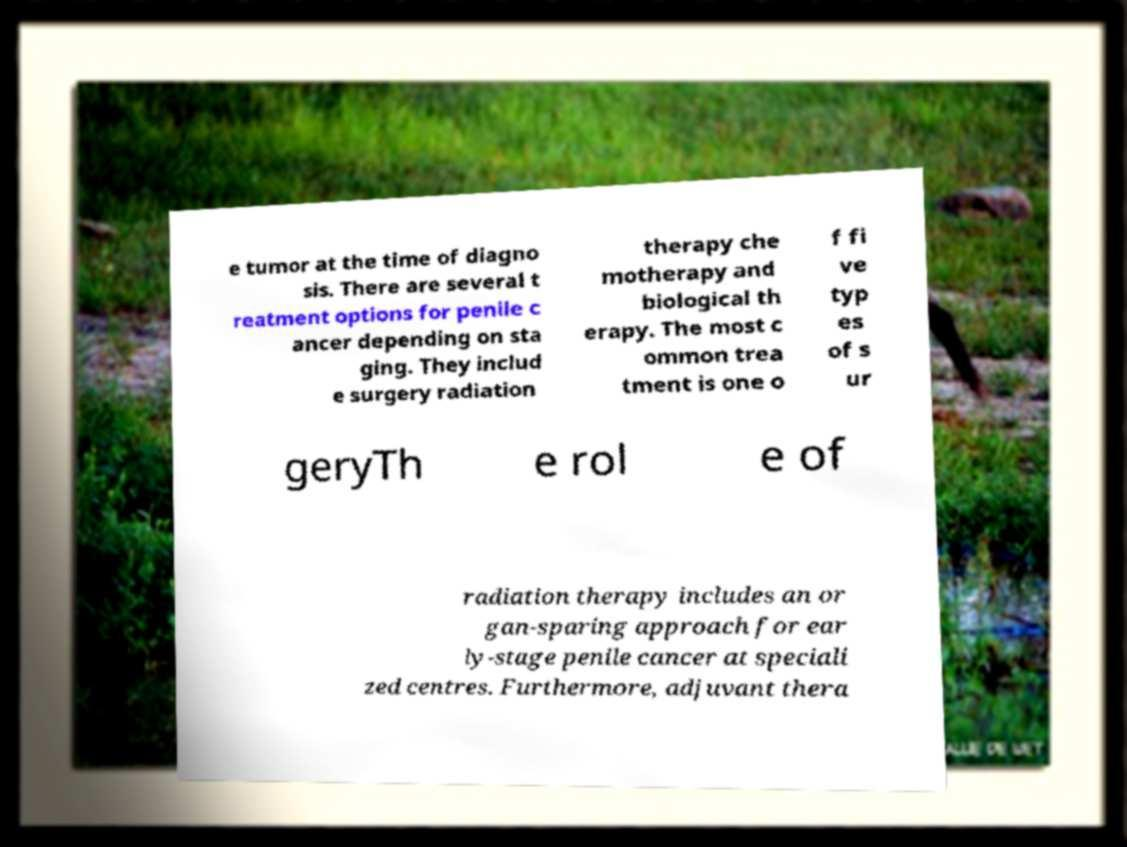For documentation purposes, I need the text within this image transcribed. Could you provide that? e tumor at the time of diagno sis. There are several t reatment options for penile c ancer depending on sta ging. They includ e surgery radiation therapy che motherapy and biological th erapy. The most c ommon trea tment is one o f fi ve typ es of s ur geryTh e rol e of radiation therapy includes an or gan-sparing approach for ear ly-stage penile cancer at speciali zed centres. Furthermore, adjuvant thera 